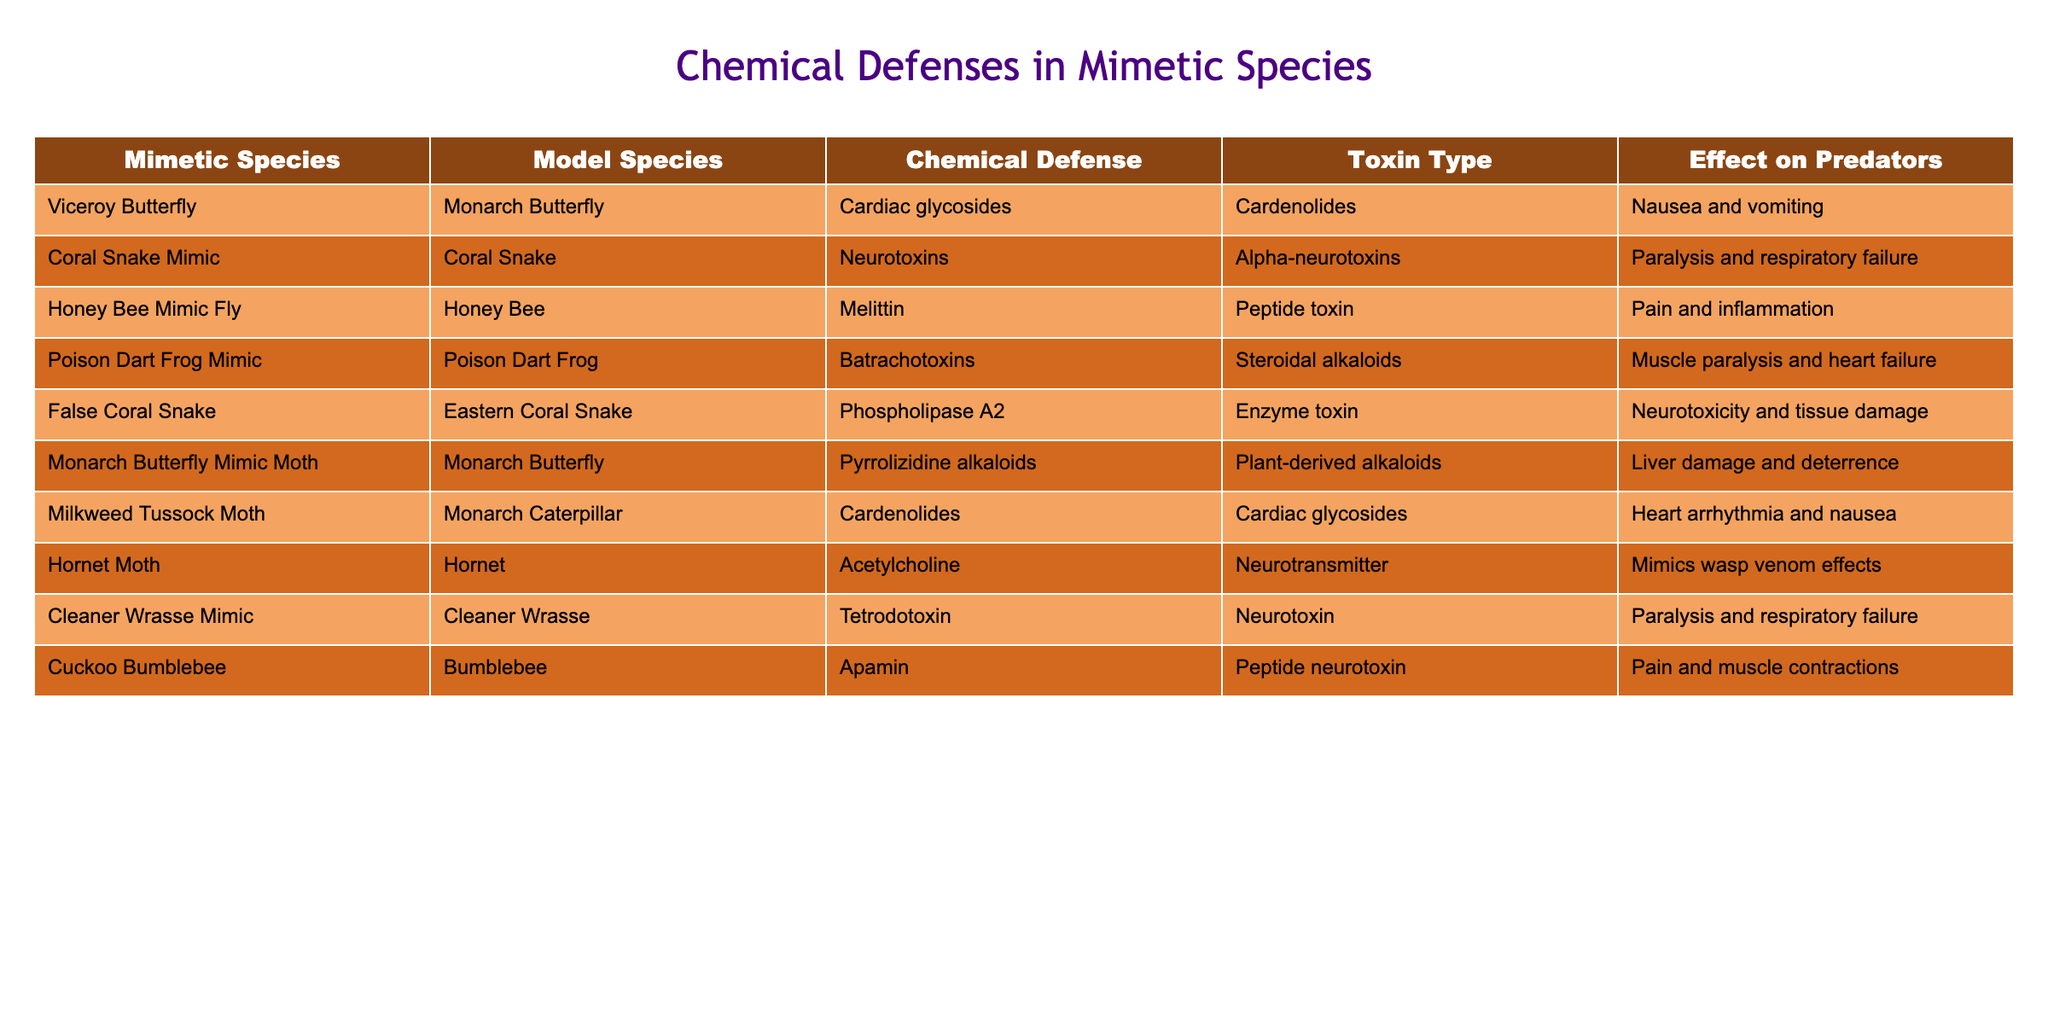What chemical defense do the Viceroy Butterfly and the Monarch Butterfly share? The table shows that both the Viceroy Butterfly and the Monarch Butterfly utilize Cardiac glycosides as their chemical defense.
Answer: Cardiac glycosides How many different toxin types are listed in the table? By reviewing the "Toxin Type" column, we find that there are five distinct types: Cardiac glycosides, Alpha-neurotoxins, Peptide toxin, Steroidal alkaloids, and Enzyme toxin, which totals to five.
Answer: 5 Does the False Coral Snake employ a neurotoxin? The table indicates that the False Coral Snake uses Phospholipase A2, which is classified as an enzyme toxin, not specifically a neurotoxin. Therefore, the statement is false.
Answer: No What is the effect on predators for the Honey Bee Mimic Fly? According to the table, the effect on predators for the Honey Bee Mimic Fly is pain and inflammation.
Answer: Pain and inflammation Which chemical defenses cause muscle paralysis? Both the Coral Snake Mimic and the Poison Dart Frog Mimic employ chemical defenses (i.e., Neurotoxins and Batrachotoxins respectively) that lead to muscle paralysis, as described in the "Effect on Predators" column.
Answer: Neurotoxins and Batrachotoxins Are all mimetic species in the table linked to a model that uses toxin types? Yes, every mimetic species listed is associated with a model species that employs some form of chemical defense or toxin.
Answer: Yes What is the most severe effect reported in the table for any mimetic species? The Poison Dart Frog Mimic lists the effect as muscle paralysis and heart failure, which is a severe outcome compared to others.
Answer: Muscle paralysis and heart failure Which mimetic species uses Pyrrolizidine alkaloids as their chemical defense? The Monarch Butterfly Mimic Moth is noted in the table as using Pyrrolizidine alkaloids for their chemical defense.
Answer: Monarch Butterfly Mimic Moth Can you find any mimetic species that utilize enzymes as their chemical defense? Yes, the False Coral Snake employs Phospholipase A2 as its chemical defense, which is an enzyme toxin.
Answer: Yes What is the relationship between the Cuckoo Bumblebee and the Bumblebee concerning chemical defense? The Cuckoo Bumblebee mimics the Bumblebee and uses apamin, a peptide neurotoxin, as its chemical defense, reflecting the defensive strategies of its model.
Answer: Mimics and uses apamin 